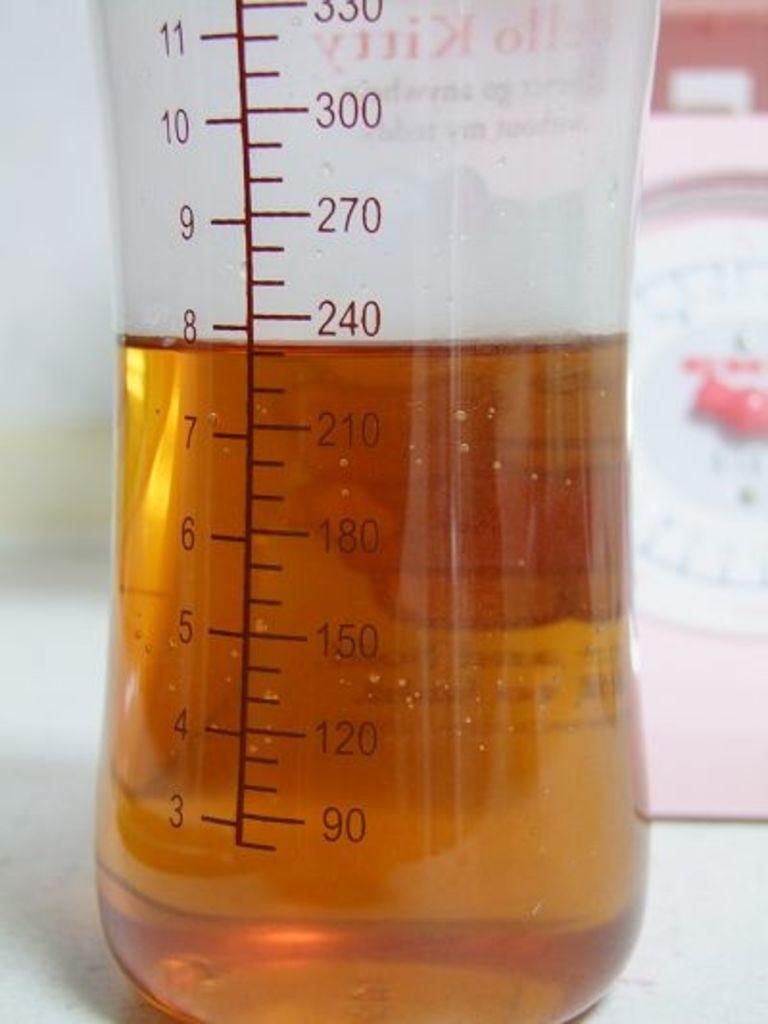How much vinegar is in that?
Give a very brief answer. 230. What is the lowest amount?
Make the answer very short. 3. 